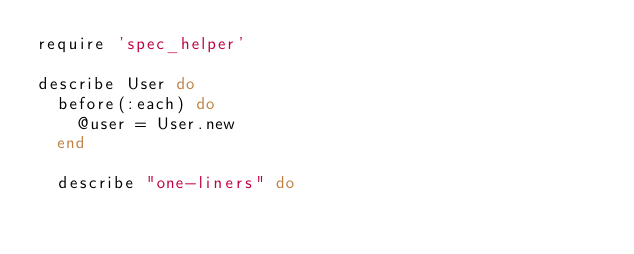Convert code to text. <code><loc_0><loc_0><loc_500><loc_500><_Ruby_>require 'spec_helper'

describe User do
  before(:each) do
    @user = User.new
  end

  describe "one-liners" do</code> 